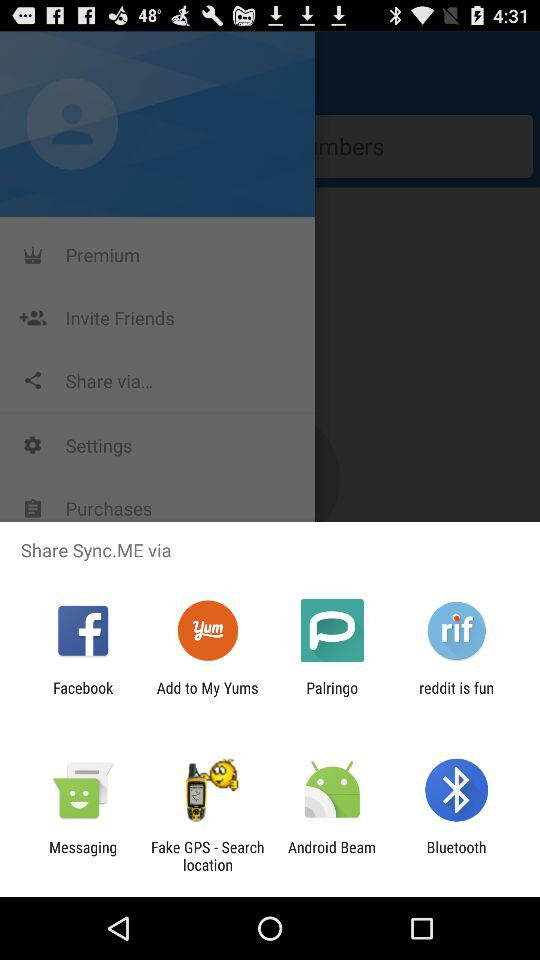What are the available sharing options? The available sharing options are "Facebook", "Add to My Yums", "Palringo", "reddit is fun", "Messaging", "Fake GPS - Search location", "Android Beam" and "Bluetooth". 